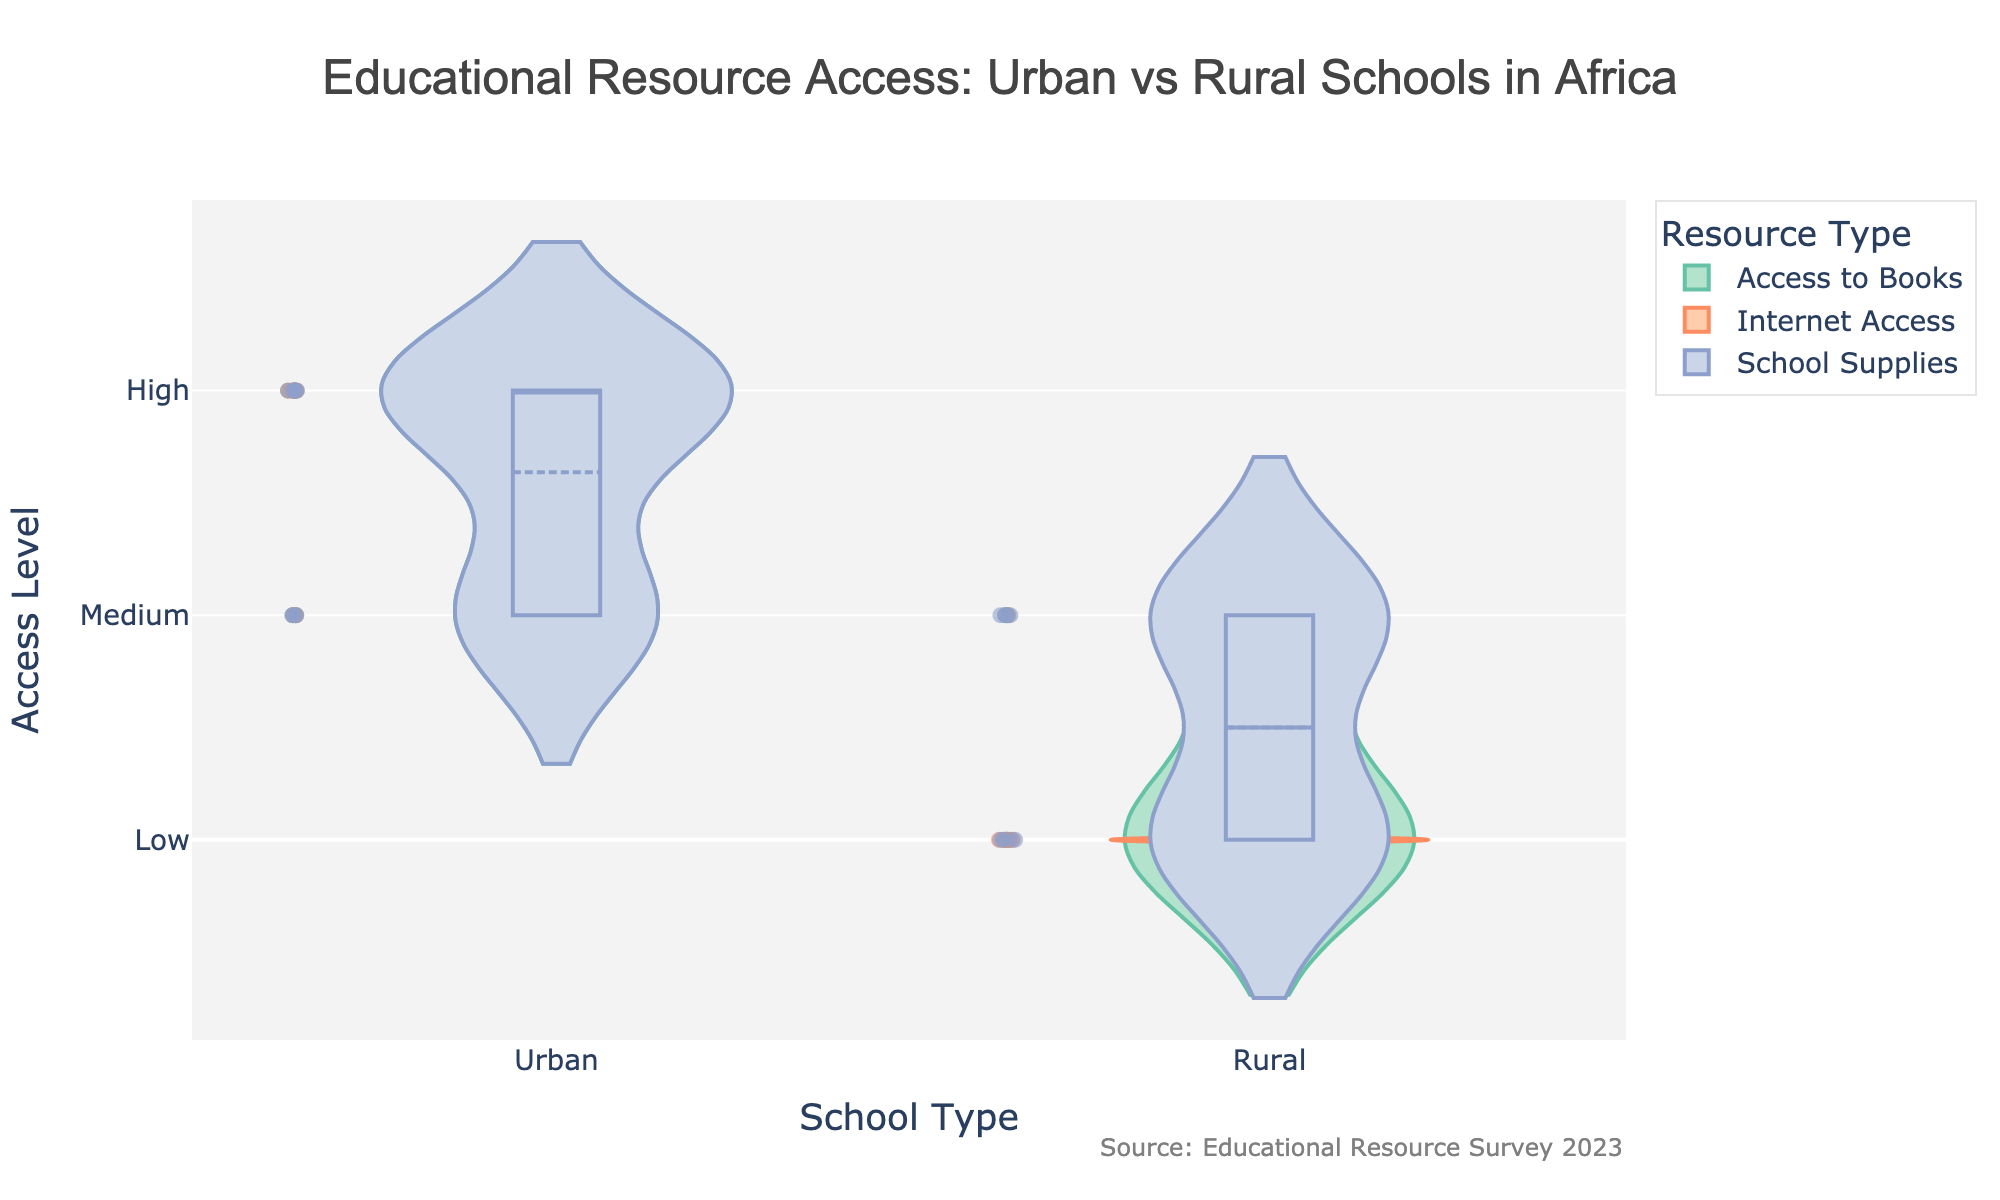What's the title of the figure? The title is located at the top of the figure.
Answer: Educational Resource Access: Urban vs Rural Schools in Africa What are the categories on the x-axis? The x-axis categories are specified at the bottom of the figure.
Answer: School Type What does the y-axis represent? The y-axis title is displayed on the left side of the figure.
Answer: Access Level How many access levels are shown on the y-axis? Count the tick values on the y-axis.
Answer: 3 (Low, Medium, High) Which school type generally has higher access to the internet? Violin plot for 'Internet Access' shows higher density towards 'High' and 'Medium' for Urban schools compared to Rural schools.
Answer: Urban In which category do Rural schools have the most variability? Look for the widest spread (height) in the violin plots for Rural schools.
Answer: Access to Books Which resource type shows the least variability among Urban schools? Look for the narrowest spread (height) in the violin plots for Urban schools.
Answer: School Supplies How does the access to school supplies compare between Urban and Rural schools? Observe the median line and spread of the violin plots for 'School Supplies' for both Urban and Rural categories.
Answer: Higher in Urban schools What type of schools has higher variability in internet access? Compare the spread of violin plots for 'Internet Access' in both school types; greater spread indicates more variability.
Answer: Rural Which type of resource seems equally distributed between Urban and Rural schools? Check if any violin plots for Urban and Rural categories overlap significantly in distribution.
Answer: None 